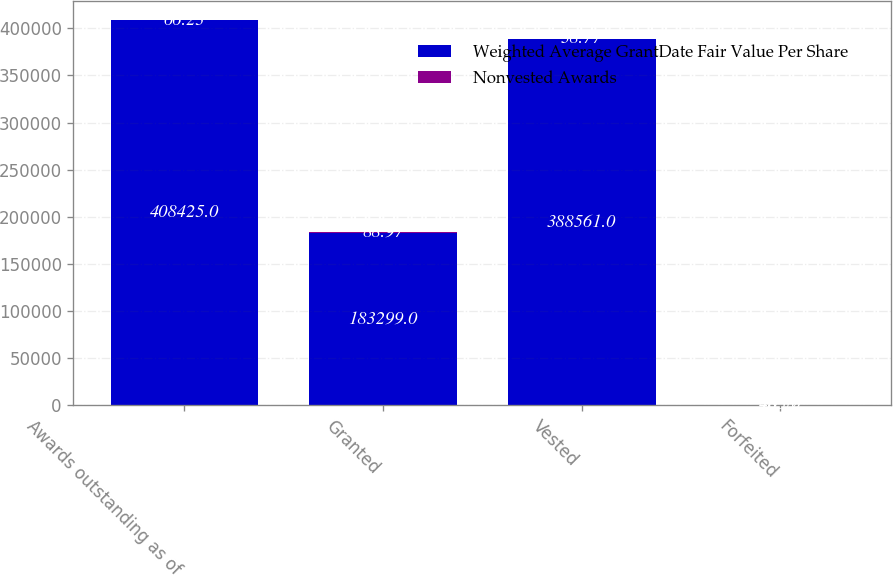Convert chart. <chart><loc_0><loc_0><loc_500><loc_500><stacked_bar_chart><ecel><fcel>Awards outstanding as of<fcel>Granted<fcel>Vested<fcel>Forfeited<nl><fcel>Weighted Average GrantDate Fair Value Per Share<fcel>408425<fcel>183299<fcel>388561<fcel>703<nl><fcel>Nonvested Awards<fcel>66.23<fcel>88.97<fcel>38.77<fcel>48.57<nl></chart> 